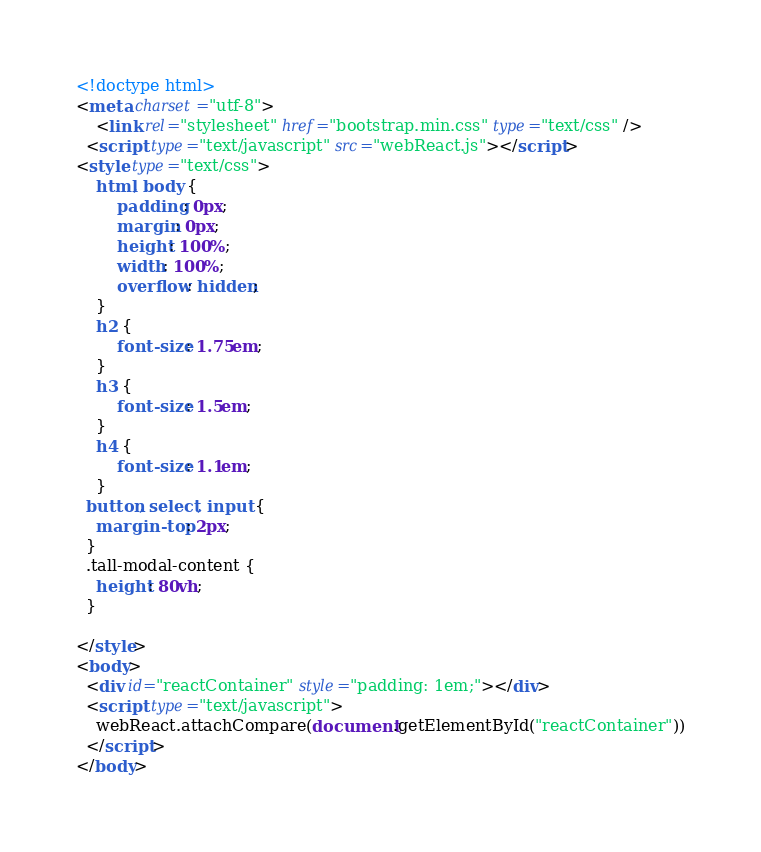Convert code to text. <code><loc_0><loc_0><loc_500><loc_500><_HTML_><!doctype html>
<meta charset="utf-8">
	<link rel="stylesheet" href="bootstrap.min.css" type="text/css" />
  <script type="text/javascript" src="webReact.js"></script>
<style type="text/css">
	html, body {
		padding: 0px;
		margin: 0px;
		height: 100%;
		width: 100%;
		overflow: hidden;
	}
	h2 {
		font-size: 1.75em;
	}
	h3 {
		font-size: 1.5em;
	}
	h4 {
		font-size: 1.1em;
	}
  button, select, input {
    margin-top: 2px;
  }
  .tall-modal-content {
    height: 80vh;
  }

</style>
<body>
  <div id="reactContainer" style="padding: 1em;"></div>
  <script type="text/javascript">
    webReact.attachCompare(document.getElementById("reactContainer"))
  </script>
</body>
</code> 